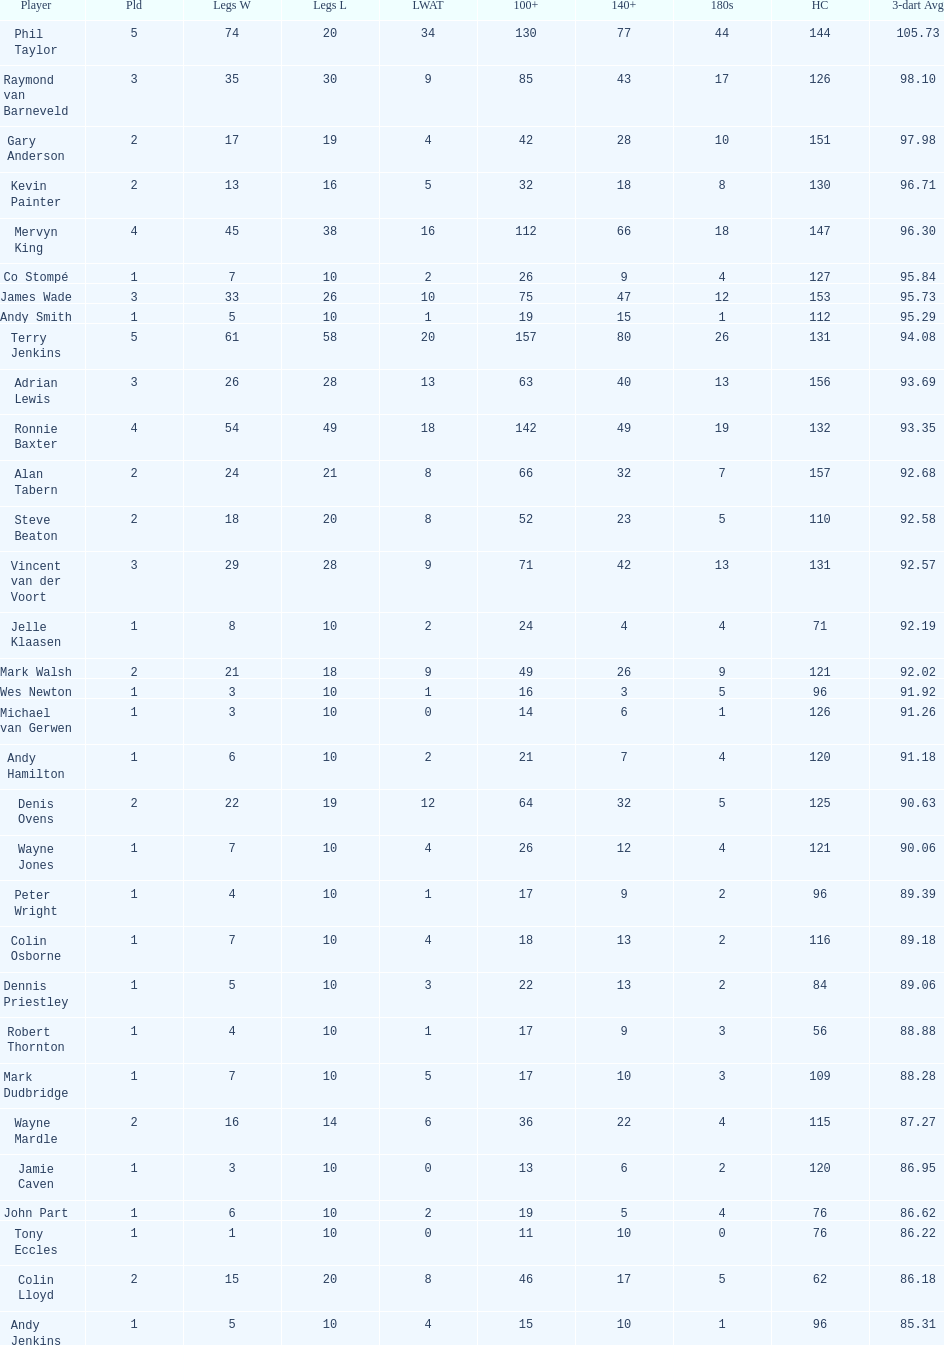What are the number of legs lost by james wade? 26. Parse the full table. {'header': ['Player', 'Pld', 'Legs W', 'Legs L', 'LWAT', '100+', '140+', '180s', 'HC', '3-dart Avg'], 'rows': [['Phil Taylor', '5', '74', '20', '34', '130', '77', '44', '144', '105.73'], ['Raymond van Barneveld', '3', '35', '30', '9', '85', '43', '17', '126', '98.10'], ['Gary Anderson', '2', '17', '19', '4', '42', '28', '10', '151', '97.98'], ['Kevin Painter', '2', '13', '16', '5', '32', '18', '8', '130', '96.71'], ['Mervyn King', '4', '45', '38', '16', '112', '66', '18', '147', '96.30'], ['Co Stompé', '1', '7', '10', '2', '26', '9', '4', '127', '95.84'], ['James Wade', '3', '33', '26', '10', '75', '47', '12', '153', '95.73'], ['Andy Smith', '1', '5', '10', '1', '19', '15', '1', '112', '95.29'], ['Terry Jenkins', '5', '61', '58', '20', '157', '80', '26', '131', '94.08'], ['Adrian Lewis', '3', '26', '28', '13', '63', '40', '13', '156', '93.69'], ['Ronnie Baxter', '4', '54', '49', '18', '142', '49', '19', '132', '93.35'], ['Alan Tabern', '2', '24', '21', '8', '66', '32', '7', '157', '92.68'], ['Steve Beaton', '2', '18', '20', '8', '52', '23', '5', '110', '92.58'], ['Vincent van der Voort', '3', '29', '28', '9', '71', '42', '13', '131', '92.57'], ['Jelle Klaasen', '1', '8', '10', '2', '24', '4', '4', '71', '92.19'], ['Mark Walsh', '2', '21', '18', '9', '49', '26', '9', '121', '92.02'], ['Wes Newton', '1', '3', '10', '1', '16', '3', '5', '96', '91.92'], ['Michael van Gerwen', '1', '3', '10', '0', '14', '6', '1', '126', '91.26'], ['Andy Hamilton', '1', '6', '10', '2', '21', '7', '4', '120', '91.18'], ['Denis Ovens', '2', '22', '19', '12', '64', '32', '5', '125', '90.63'], ['Wayne Jones', '1', '7', '10', '4', '26', '12', '4', '121', '90.06'], ['Peter Wright', '1', '4', '10', '1', '17', '9', '2', '96', '89.39'], ['Colin Osborne', '1', '7', '10', '4', '18', '13', '2', '116', '89.18'], ['Dennis Priestley', '1', '5', '10', '3', '22', '13', '2', '84', '89.06'], ['Robert Thornton', '1', '4', '10', '1', '17', '9', '3', '56', '88.88'], ['Mark Dudbridge', '1', '7', '10', '5', '17', '10', '3', '109', '88.28'], ['Wayne Mardle', '2', '16', '14', '6', '36', '22', '4', '115', '87.27'], ['Jamie Caven', '1', '3', '10', '0', '13', '6', '2', '120', '86.95'], ['John Part', '1', '6', '10', '2', '19', '5', '4', '76', '86.62'], ['Tony Eccles', '1', '1', '10', '0', '11', '10', '0', '76', '86.22'], ['Colin Lloyd', '2', '15', '20', '8', '46', '17', '5', '62', '86.18'], ['Andy Jenkins', '1', '5', '10', '4', '15', '10', '1', '96', '85.31']]} 